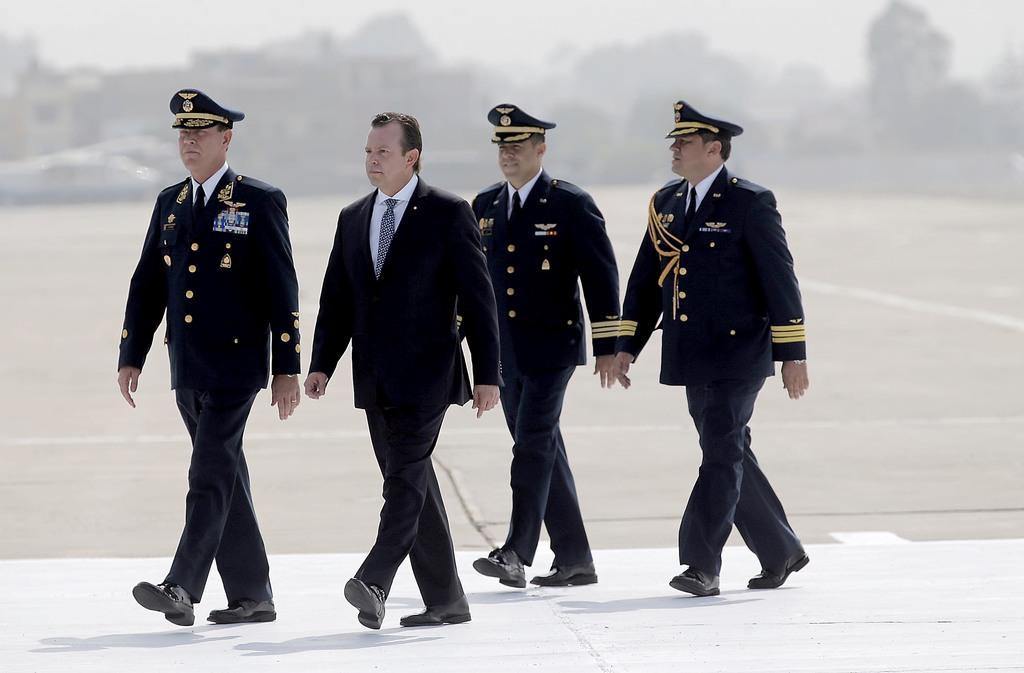How would you summarize this image in a sentence or two? In this image, we can see four persons are walking on the path. Background there is a blur view. 